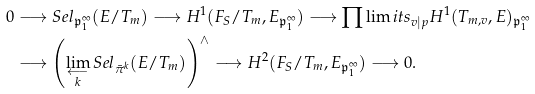<formula> <loc_0><loc_0><loc_500><loc_500>0 & \longrightarrow { S e l } _ { \mathfrak { p } _ { 1 } ^ { \infty } } ( E / T _ { m } ) \longrightarrow { H ^ { 1 } ( F _ { S } / T _ { m } , E _ { \mathfrak { p } _ { 1 } ^ { \infty } } ) } \longrightarrow { \prod \lim i t s _ { v | p } H ^ { 1 } ( T _ { m , v } , E ) _ { \mathfrak { p } _ { 1 } ^ { \infty } } } \\ & \longrightarrow { \left ( { { \lim _ { \substack { \longleftarrow \\ k } } { { S e l } _ { \bar { \pi } ^ { k } } ( E / T _ { m } ) } } } \right ) } ^ { \wedge } \longrightarrow { H ^ { 2 } ( F _ { S } / T _ { m } , E _ { \mathfrak { p } _ { 1 } ^ { \infty } } ) } \longrightarrow 0 .</formula> 